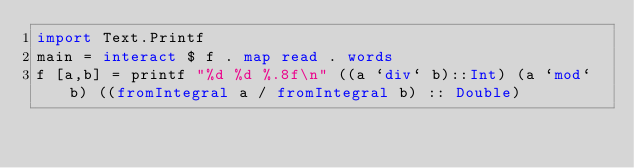Convert code to text. <code><loc_0><loc_0><loc_500><loc_500><_Haskell_>import Text.Printf
main = interact $ f . map read . words
f [a,b] = printf "%d %d %.8f\n" ((a `div` b)::Int) (a `mod` b) ((fromIntegral a / fromIntegral b) :: Double)</code> 